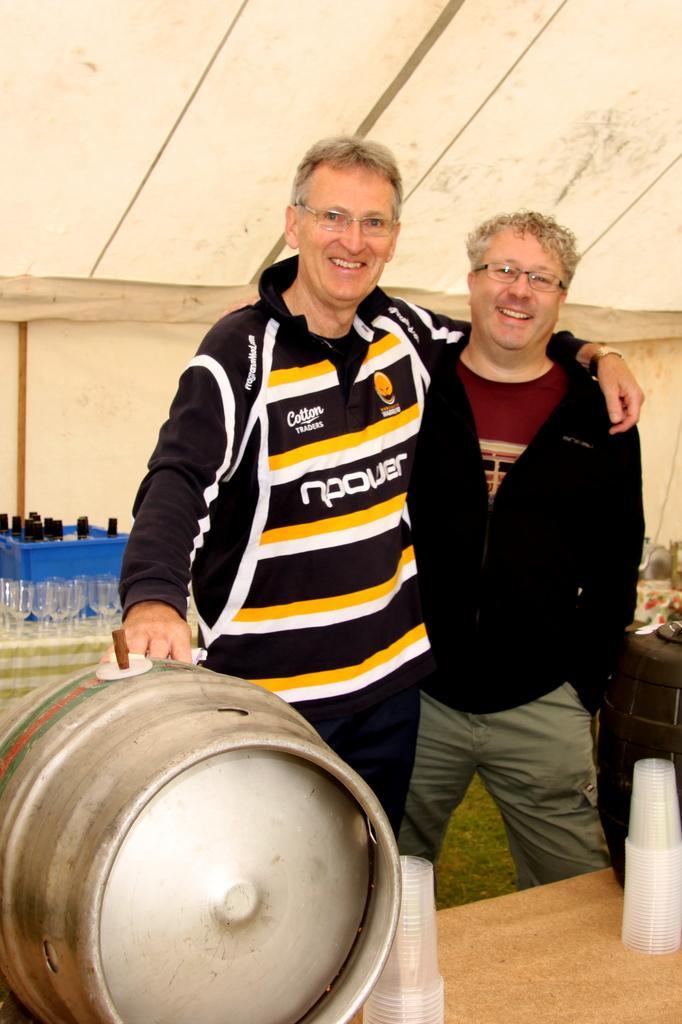In one or two sentences, can you explain what this image depicts? Here we can see two persons are standing and smiling. At the bottom there is a barrel,transparent glasses and other objects on a platform. In the background we can see glasses,wine bottles in a box are on a platform on the left side and other objects and this is a tent. 